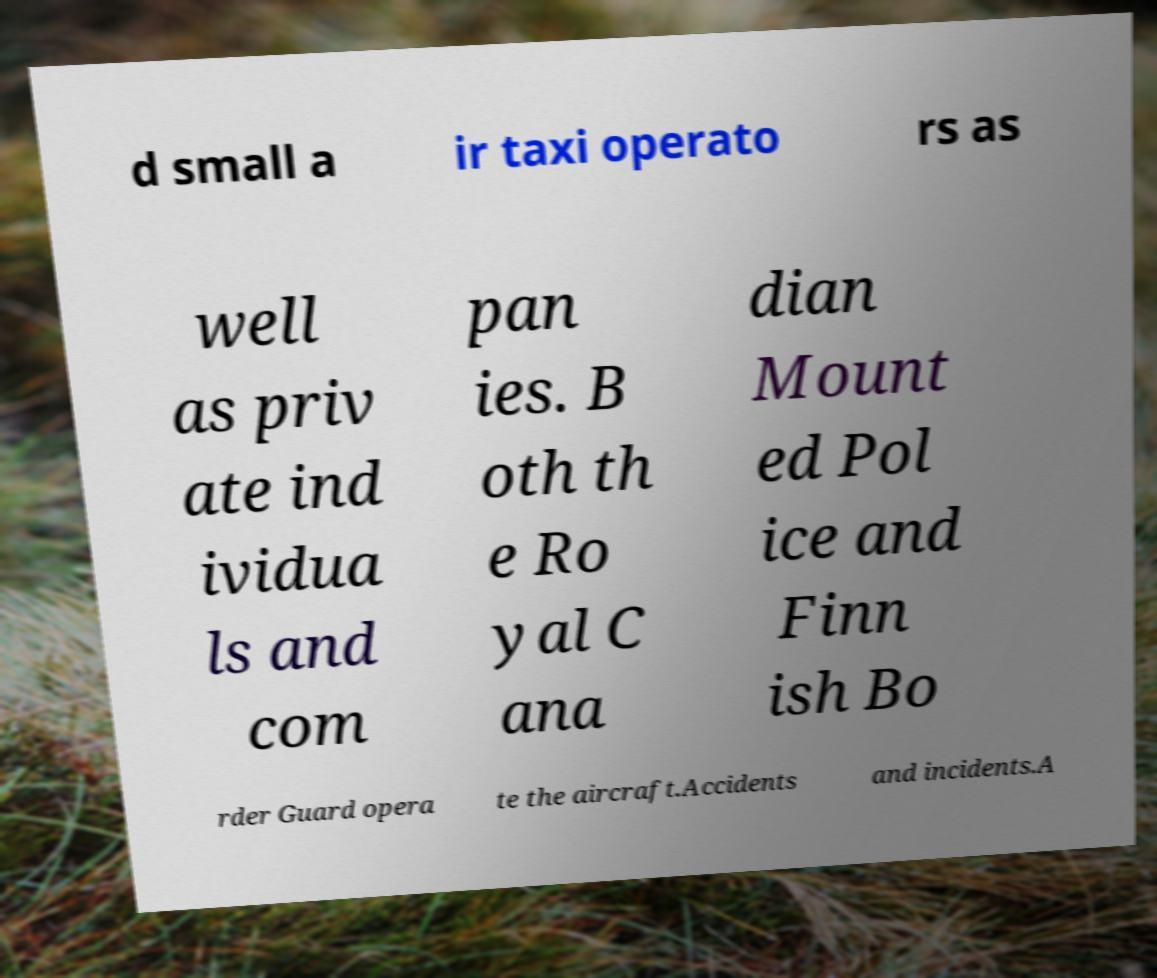There's text embedded in this image that I need extracted. Can you transcribe it verbatim? d small a ir taxi operato rs as well as priv ate ind ividua ls and com pan ies. B oth th e Ro yal C ana dian Mount ed Pol ice and Finn ish Bo rder Guard opera te the aircraft.Accidents and incidents.A 